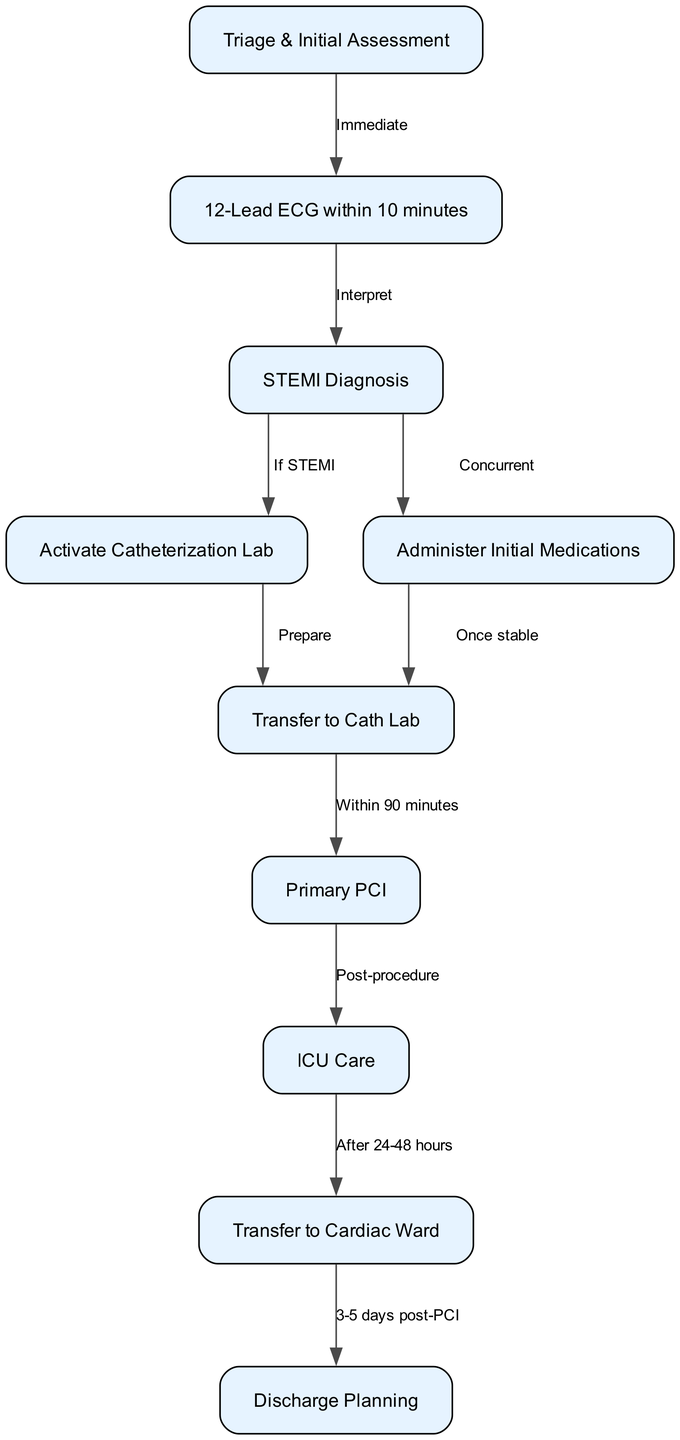What is the first step in the pathway? The first step, as indicated by the initial node in the diagram, is "Triage & Initial Assessment." It is the starting point of the clinical pathway for managing acute myocardial infarction.
Answer: Triage & Initial Assessment How many nodes are there in total? By counting all the individual steps or stages shown in the diagram, we see there are a total of 10 nodes representing different parts of the acute myocardial infarction management pathway.
Answer: 10 What medication administration is indicated alongside the STEMI diagnosis? The diagram shows that "Administer Initial Medications" occurs concurrently with the "STEMI Diagnosis," meaning medications should be given at the same time as the diagnosis step is made.
Answer: Administer Initial Medications What is the time limit for transferring to the PCI? The diagram specifies that patients must be transferred to PCI "Within 90 minutes" following the transfer to the cath lab, which is a critical time constraint in the management pathway.
Answer: Within 90 minutes How long after the PCI is ICU care received? According to the pathway, "ICU Care" is provided "Post-procedure," meaning that patients will go to the ICU immediately after the primary PCI procedure is complete.
Answer: Post-procedure What happens after ICU care? After receiving "ICU Care," the next step indicated in the pathway is to "Transfer to Cardiac Ward." This outlines the patient flow following critical care.
Answer: Transfer to Cardiac Ward When does discharge planning occur? The diagram indicates that "Discharge Planning" occurs "3-5 days post-PCI," outlining the timeframe within which the planning for patient discharge should start after the procedure.
Answer: 3-5 days post-PCI What should happen once the patient is stable but before transfer? The pathway indicates that medications should be administered "Once stable," which is a prerequisite before transferring to the catheterization lab.
Answer: Once stable What immediate action follows the triage step? Following the "Triage & Initial Assessment," the immediate action taken is to perform a "12-Lead ECG within 10 minutes," which is a critical diagnostic step in acute myocardial infarction management.
Answer: 12-Lead ECG within 10 minutes What is the condition for activating the catheterization lab? The condition to "Activate Catheterization Lab" is based on the result of the "STEMI Diagnosis." If a STEMI is diagnosed, then the lab is activated for further intervention.
Answer: If STEMI 